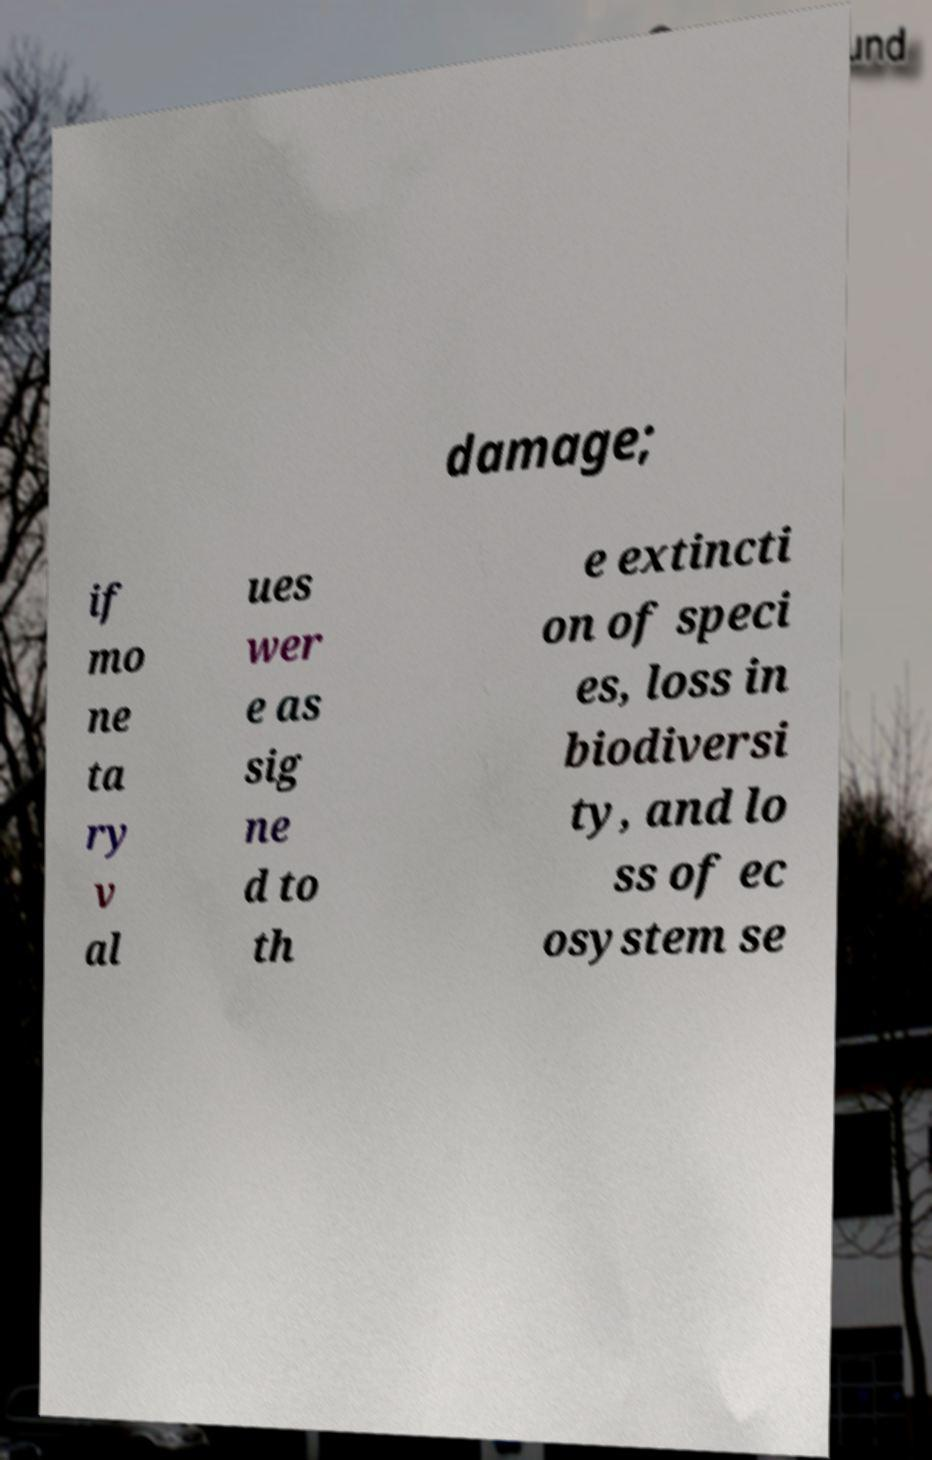Can you read and provide the text displayed in the image?This photo seems to have some interesting text. Can you extract and type it out for me? damage; if mo ne ta ry v al ues wer e as sig ne d to th e extincti on of speci es, loss in biodiversi ty, and lo ss of ec osystem se 